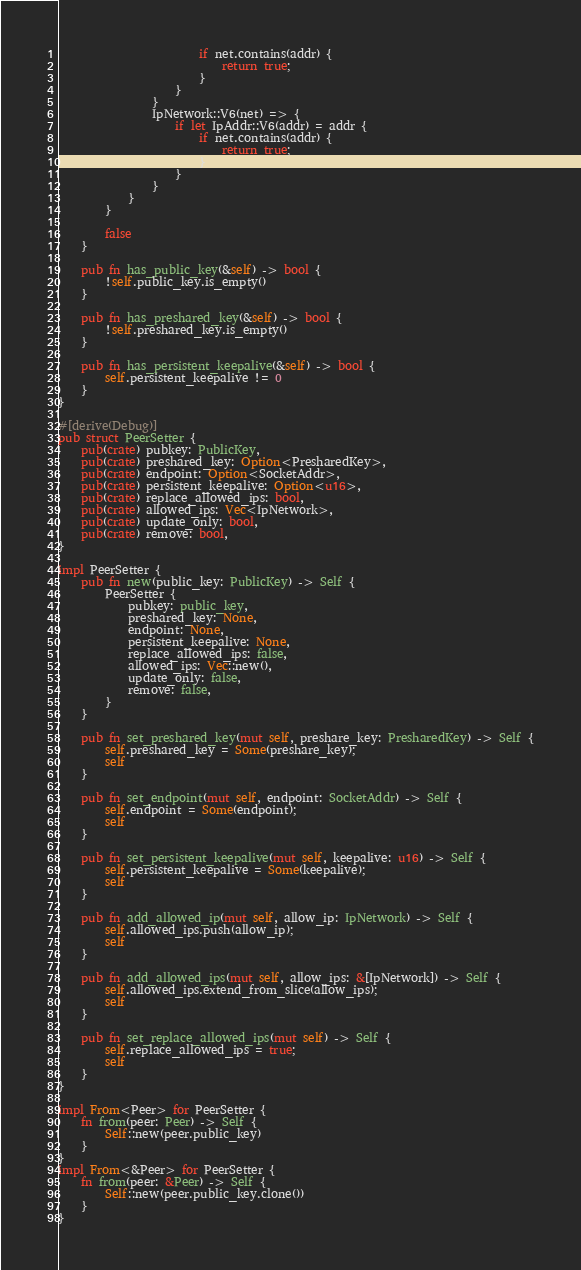<code> <loc_0><loc_0><loc_500><loc_500><_Rust_>                        if net.contains(addr) {
                            return true;
                        }
                    }
                }
                IpNetwork::V6(net) => {
                    if let IpAddr::V6(addr) = addr {
                        if net.contains(addr) {
                            return true;
                        }
                    }
                }
            }
        }

        false
    }

    pub fn has_public_key(&self) -> bool {
        !self.public_key.is_empty()
    }

    pub fn has_preshared_key(&self) -> bool {
        !self.preshared_key.is_empty()
    }

    pub fn has_persistent_keepalive(&self) -> bool {
        self.persistent_keepalive != 0
    }
}

#[derive(Debug)]
pub struct PeerSetter {
    pub(crate) pubkey: PublicKey,
    pub(crate) preshared_key: Option<PresharedKey>,
    pub(crate) endpoint: Option<SocketAddr>,
    pub(crate) persistent_keepalive: Option<u16>,
    pub(crate) replace_allowed_ips: bool,
    pub(crate) allowed_ips: Vec<IpNetwork>,
    pub(crate) update_only: bool,
    pub(crate) remove: bool,
}

impl PeerSetter {
    pub fn new(public_key: PublicKey) -> Self {
        PeerSetter {
            pubkey: public_key,
            preshared_key: None,
            endpoint: None,
            persistent_keepalive: None,
            replace_allowed_ips: false,
            allowed_ips: Vec::new(),
            update_only: false,
            remove: false,
        }
    }

    pub fn set_preshared_key(mut self, preshare_key: PresharedKey) -> Self {
        self.preshared_key = Some(preshare_key);
        self
    }

    pub fn set_endpoint(mut self, endpoint: SocketAddr) -> Self {
        self.endpoint = Some(endpoint);
        self
    }

    pub fn set_persistent_keepalive(mut self, keepalive: u16) -> Self {
        self.persistent_keepalive = Some(keepalive);
        self
    }

    pub fn add_allowed_ip(mut self, allow_ip: IpNetwork) -> Self {
        self.allowed_ips.push(allow_ip);
        self
    }

    pub fn add_allowed_ips(mut self, allow_ips: &[IpNetwork]) -> Self {
        self.allowed_ips.extend_from_slice(allow_ips);
        self
    }

    pub fn set_replace_allowed_ips(mut self) -> Self {
        self.replace_allowed_ips = true;
        self
    }
}

impl From<Peer> for PeerSetter {
    fn from(peer: Peer) -> Self {
        Self::new(peer.public_key)
    }
}
impl From<&Peer> for PeerSetter {
    fn from(peer: &Peer) -> Self {
        Self::new(peer.public_key.clone())
    }
}
</code> 